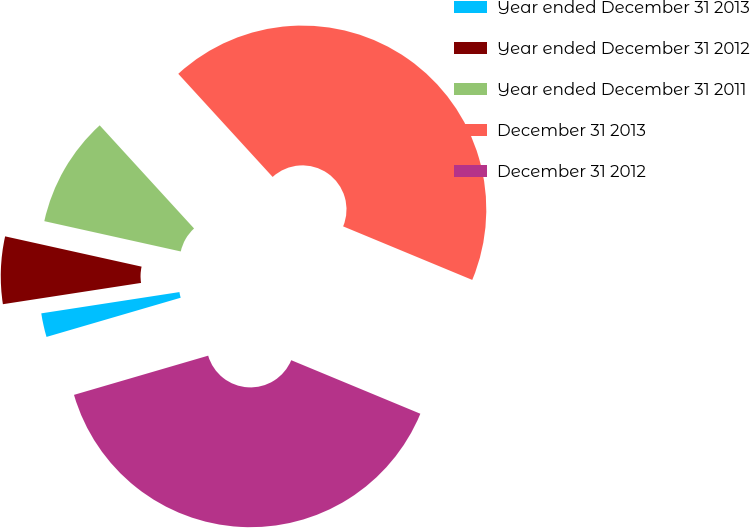<chart> <loc_0><loc_0><loc_500><loc_500><pie_chart><fcel>Year ended December 31 2013<fcel>Year ended December 31 2012<fcel>Year ended December 31 2011<fcel>December 31 2013<fcel>December 31 2012<nl><fcel>2.09%<fcel>5.91%<fcel>9.73%<fcel>43.05%<fcel>39.22%<nl></chart> 